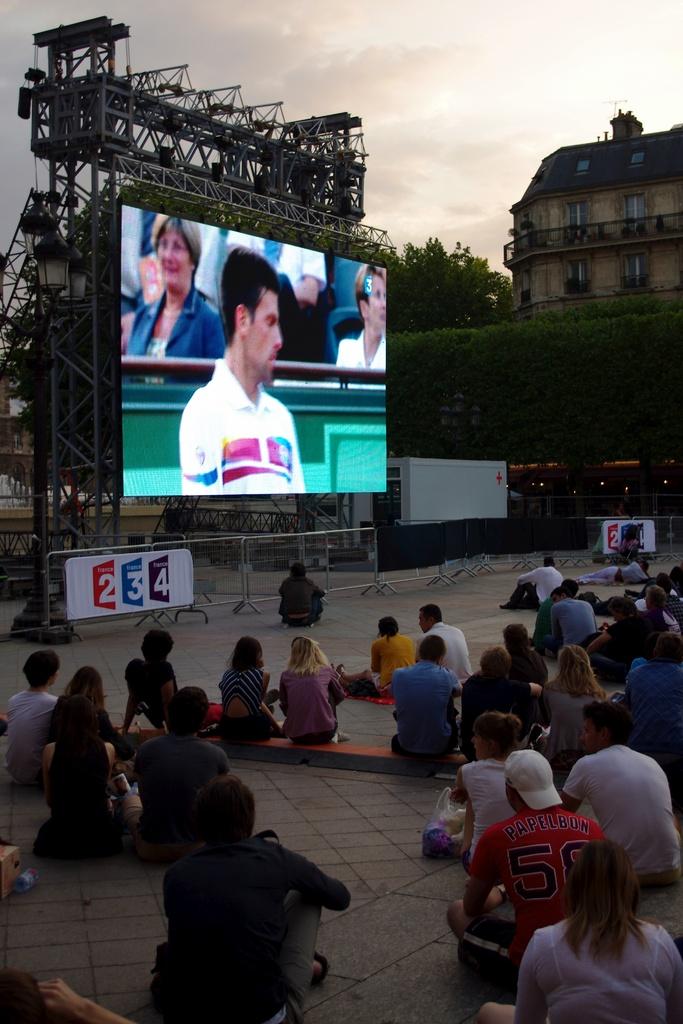What numbers are on the sign in front of the screen?
Offer a terse response. 234. 